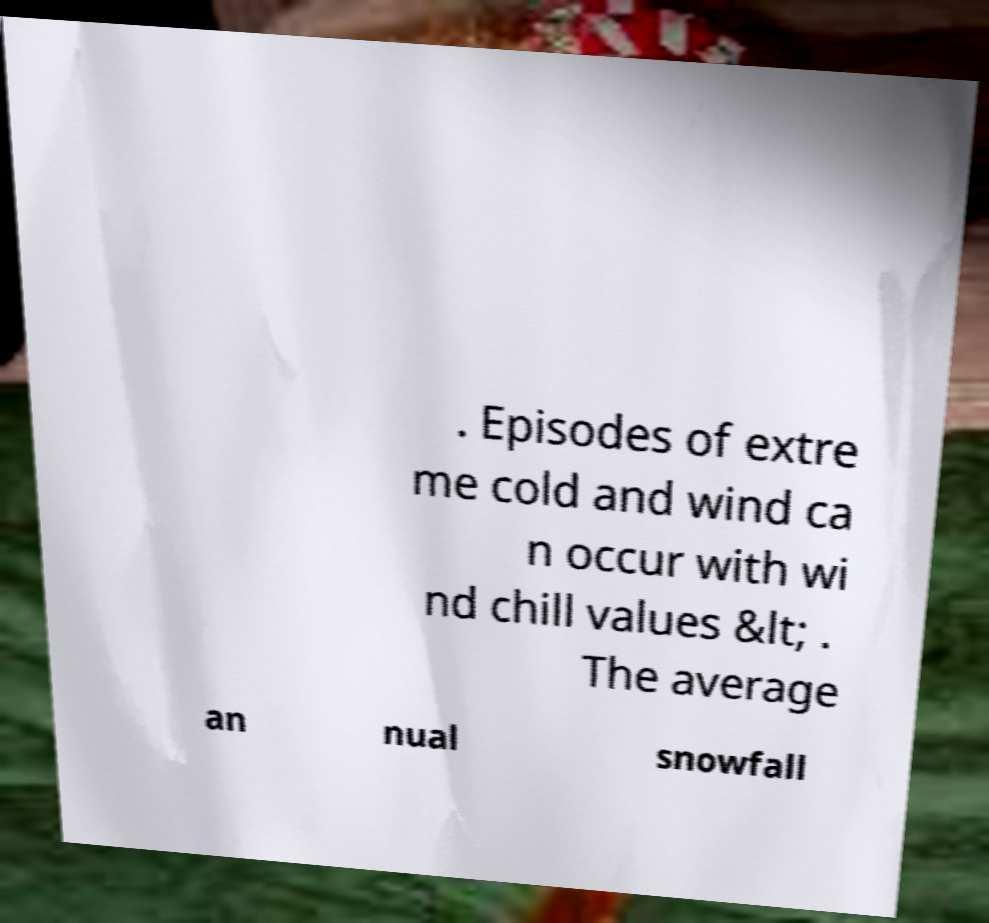Could you extract and type out the text from this image? . Episodes of extre me cold and wind ca n occur with wi nd chill values &lt; . The average an nual snowfall 